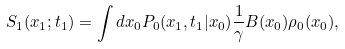<formula> <loc_0><loc_0><loc_500><loc_500>S _ { 1 } ( { x } _ { 1 } ; t _ { 1 } ) = \int d { x } _ { 0 } P _ { 0 } ( { x } _ { 1 } , t _ { 1 } | { x } _ { 0 } ) \frac { 1 } { \gamma } B ( { x } _ { 0 } ) \rho _ { 0 } ( { x } _ { 0 } ) ,</formula> 